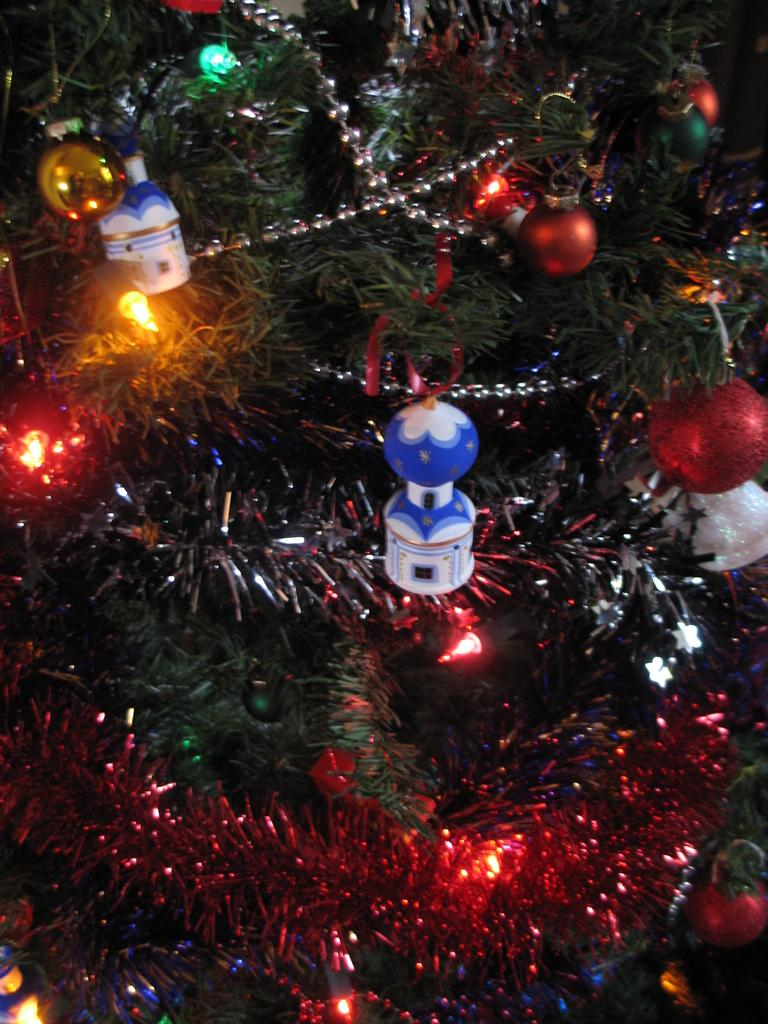What is the main feature of the tree in the image? There are lights on the Christmas tree. What else can be seen on the Christmas tree? There are toys on the Christmas tree. What type of root can be seen growing from the clam in the image? There is no clam or root present in the image; it features a Christmas tree with lights and toys. 